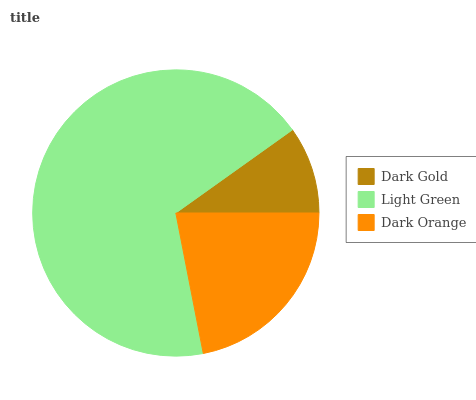Is Dark Gold the minimum?
Answer yes or no. Yes. Is Light Green the maximum?
Answer yes or no. Yes. Is Dark Orange the minimum?
Answer yes or no. No. Is Dark Orange the maximum?
Answer yes or no. No. Is Light Green greater than Dark Orange?
Answer yes or no. Yes. Is Dark Orange less than Light Green?
Answer yes or no. Yes. Is Dark Orange greater than Light Green?
Answer yes or no. No. Is Light Green less than Dark Orange?
Answer yes or no. No. Is Dark Orange the high median?
Answer yes or no. Yes. Is Dark Orange the low median?
Answer yes or no. Yes. Is Light Green the high median?
Answer yes or no. No. Is Light Green the low median?
Answer yes or no. No. 